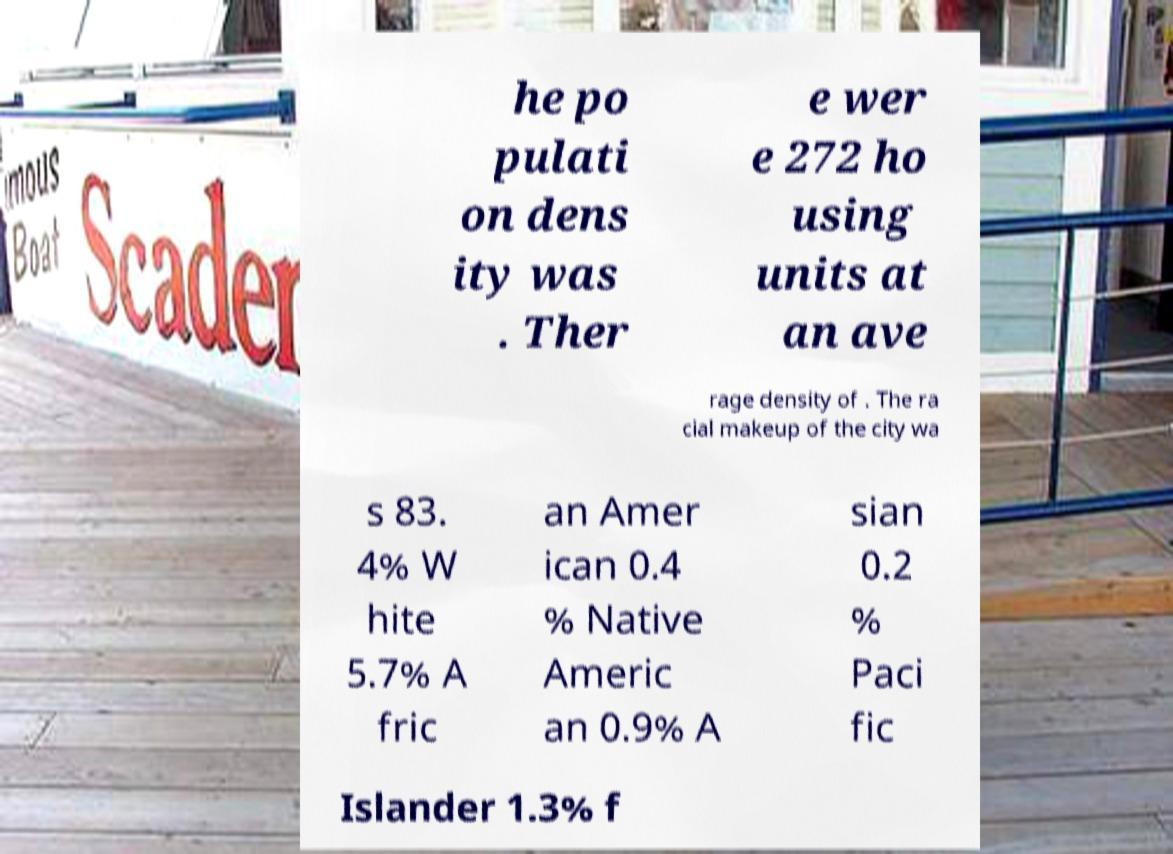Could you assist in decoding the text presented in this image and type it out clearly? he po pulati on dens ity was . Ther e wer e 272 ho using units at an ave rage density of . The ra cial makeup of the city wa s 83. 4% W hite 5.7% A fric an Amer ican 0.4 % Native Americ an 0.9% A sian 0.2 % Paci fic Islander 1.3% f 